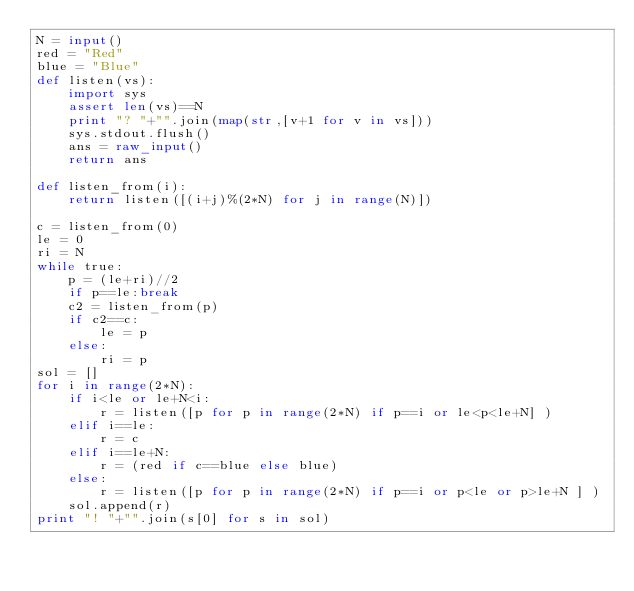Convert code to text. <code><loc_0><loc_0><loc_500><loc_500><_Python_>N = input()
red = "Red"
blue = "Blue"
def listen(vs):
    import sys
    assert len(vs)==N
    print "? "+"".join(map(str,[v+1 for v in vs]))
    sys.stdout.flush()
    ans = raw_input()
    return ans

def listen_from(i):
    return listen([(i+j)%(2*N) for j in range(N)])

c = listen_from(0)
le = 0
ri = N
while true:
    p = (le+ri)//2
    if p==le:break
    c2 = listen_from(p)
    if c2==c:
        le = p
    else:
        ri = p
sol = []
for i in range(2*N):
    if i<le or le+N<i:
        r = listen([p for p in range(2*N) if p==i or le<p<le+N] )
    elif i==le:
        r = c
    elif i==le+N:
        r = (red if c==blue else blue)
    else:
        r = listen([p for p in range(2*N) if p==i or p<le or p>le+N ] )
    sol.append(r)
print "! "+"".join(s[0] for s in sol)


</code> 